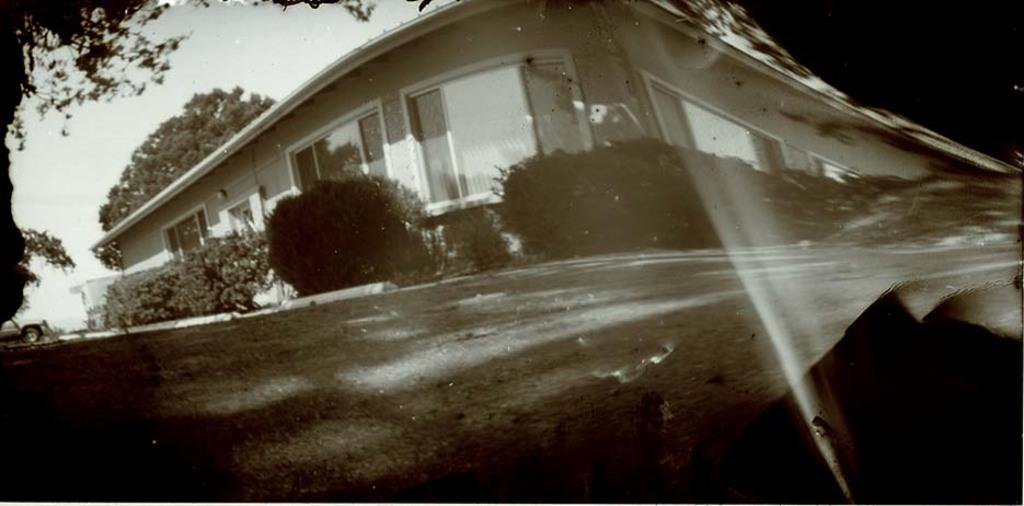What type of editing has been done to the image? The image is edited, but the specific type of editing is not mentioned in the facts. What type of vegetation can be seen in the image? There are plants in the image. What type of structure is present in the image? There is a house in the image. What is the vehicle's location in the image? The vehicle is on a path in the image. What is located behind the house in the image? There is a tree behind the house in the image. What part of the natural environment is visible in the image? The sky is visible in the image. What type of honey is being collected by the zebra in the image? There is no zebra or honey present in the image. What is the name of the scene depicted in the image? The facts provided do not give a specific name for the scene depicted in the image. 